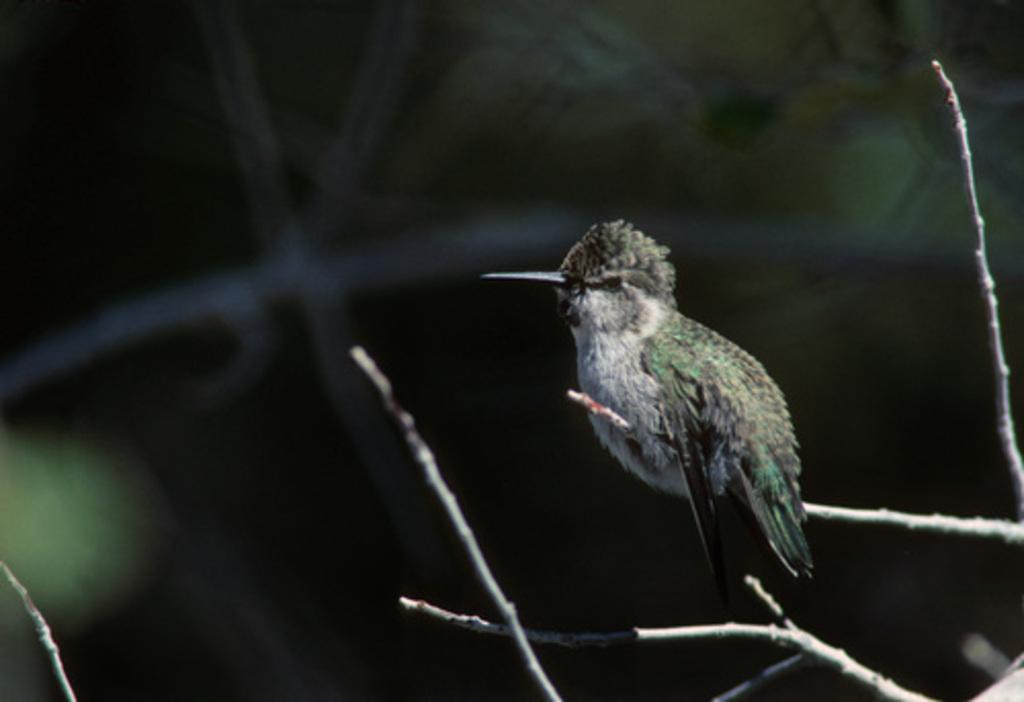What type of animal is in the image? There is a hummingbird in the image. Where is the hummingbird located? The hummingbird is on a branch. What can be observed about the background of the image? The background of the image is blurred. How many cats are taking care of the hummingbird in the image? There are no cats present in the image, and therefore no such caretaking can be observed. 